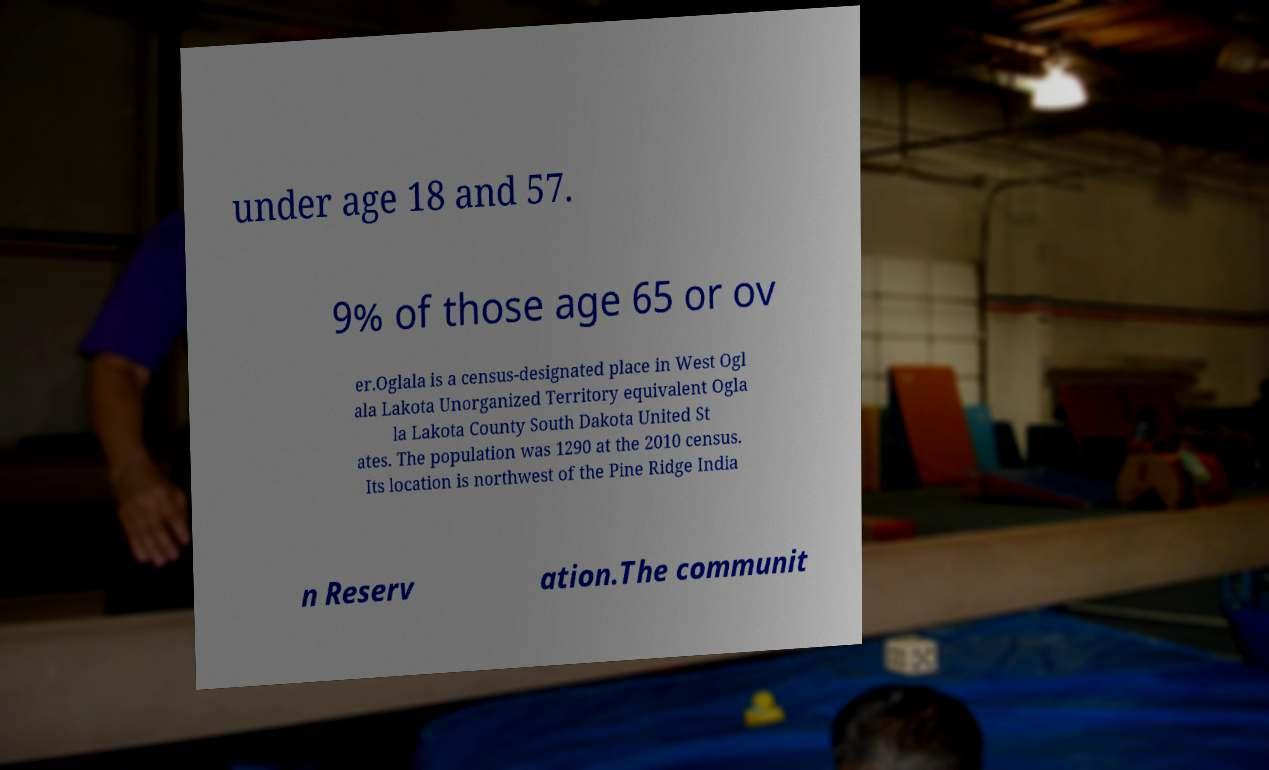Can you read and provide the text displayed in the image?This photo seems to have some interesting text. Can you extract and type it out for me? under age 18 and 57. 9% of those age 65 or ov er.Oglala is a census-designated place in West Ogl ala Lakota Unorganized Territory equivalent Ogla la Lakota County South Dakota United St ates. The population was 1290 at the 2010 census. Its location is northwest of the Pine Ridge India n Reserv ation.The communit 